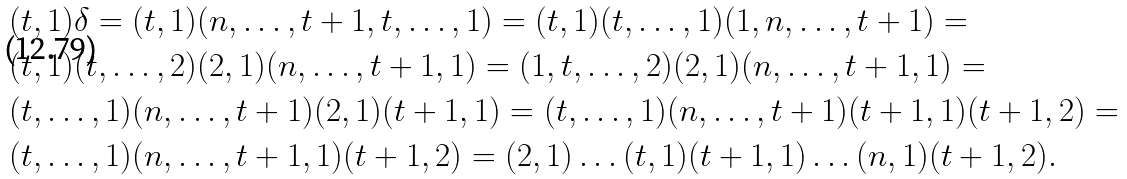Convert formula to latex. <formula><loc_0><loc_0><loc_500><loc_500>& ( t , 1 ) \delta = ( t , 1 ) ( n , \dots , t + 1 , t , \dots , 1 ) = ( t , 1 ) ( t , \dots , 1 ) ( 1 , n , \dots , t + 1 ) = \\ & ( t , 1 ) ( t , \dots , 2 ) ( 2 , 1 ) ( n , \dots , t + 1 , 1 ) = ( 1 , t , \dots , 2 ) ( 2 , 1 ) ( n , \dots , t + 1 , 1 ) = \\ & ( t , \dots , 1 ) ( n , \dots , t + 1 ) ( 2 , 1 ) ( t + 1 , 1 ) = ( t , \dots , 1 ) ( n , \dots , t + 1 ) ( t + 1 , 1 ) ( t + 1 , 2 ) = \\ & ( t , \dots , 1 ) ( n , \dots , t + 1 , 1 ) ( t + 1 , 2 ) = ( 2 , 1 ) \dots ( t , 1 ) ( t + 1 , 1 ) \dots ( n , 1 ) ( t + 1 , 2 ) .</formula> 